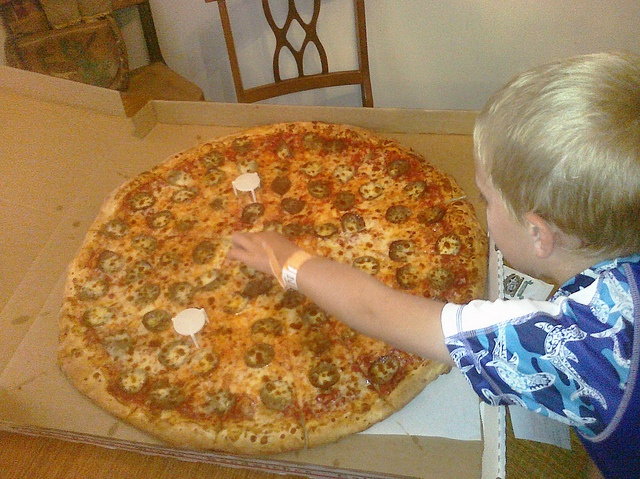Describe the objects in this image and their specific colors. I can see pizza in olive, brown, tan, and orange tones, people in olive, tan, darkgray, and white tones, chair in olive, maroon, and black tones, and chair in olive, gray, maroon, and darkgray tones in this image. 